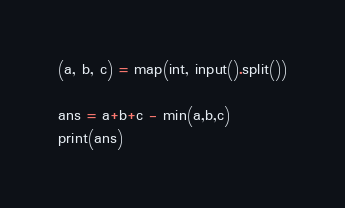<code> <loc_0><loc_0><loc_500><loc_500><_Python_>(a, b, c) = map(int, input().split())

ans = a+b+c - min(a,b,c)
print(ans)</code> 